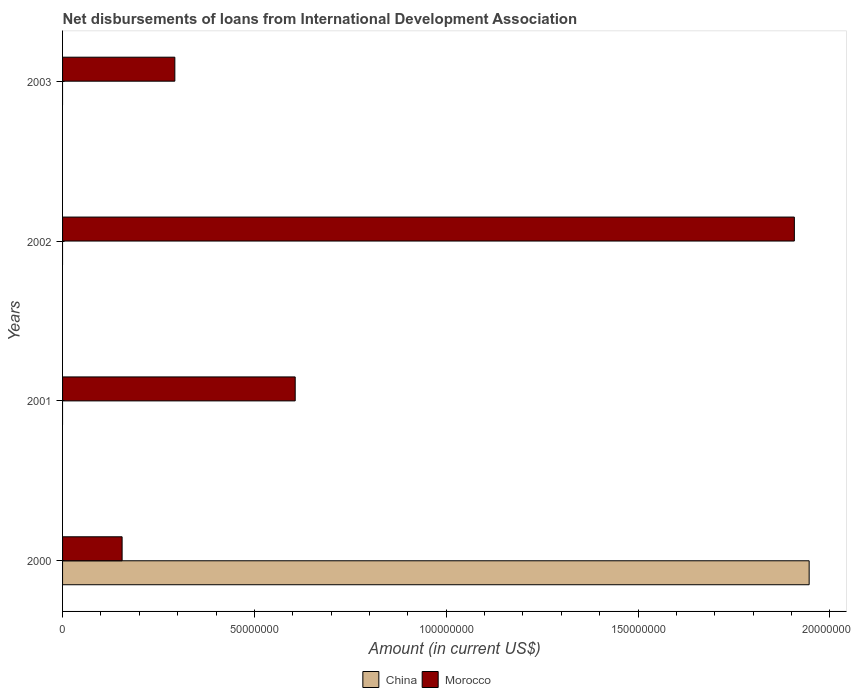Are the number of bars per tick equal to the number of legend labels?
Ensure brevity in your answer.  No. What is the label of the 3rd group of bars from the top?
Give a very brief answer. 2001. In how many cases, is the number of bars for a given year not equal to the number of legend labels?
Your response must be concise. 3. What is the amount of loans disbursed in Morocco in 2002?
Your response must be concise. 1.91e+08. Across all years, what is the maximum amount of loans disbursed in China?
Ensure brevity in your answer.  1.95e+08. Across all years, what is the minimum amount of loans disbursed in China?
Provide a succinct answer. 0. What is the total amount of loans disbursed in China in the graph?
Offer a very short reply. 1.95e+08. What is the difference between the amount of loans disbursed in Morocco in 2002 and that in 2003?
Ensure brevity in your answer.  1.61e+08. What is the difference between the amount of loans disbursed in Morocco in 2001 and the amount of loans disbursed in China in 2002?
Offer a terse response. 6.06e+07. What is the average amount of loans disbursed in China per year?
Offer a very short reply. 4.86e+07. In the year 2000, what is the difference between the amount of loans disbursed in Morocco and amount of loans disbursed in China?
Your response must be concise. -1.79e+08. In how many years, is the amount of loans disbursed in Morocco greater than 40000000 US$?
Provide a short and direct response. 2. What is the ratio of the amount of loans disbursed in Morocco in 2002 to that in 2003?
Provide a succinct answer. 6.52. Is the amount of loans disbursed in Morocco in 2000 less than that in 2003?
Offer a very short reply. Yes. What is the difference between the highest and the lowest amount of loans disbursed in Morocco?
Offer a terse response. 1.75e+08. Are the values on the major ticks of X-axis written in scientific E-notation?
Keep it short and to the point. No. Does the graph contain any zero values?
Ensure brevity in your answer.  Yes. Does the graph contain grids?
Provide a short and direct response. No. How many legend labels are there?
Provide a short and direct response. 2. How are the legend labels stacked?
Provide a succinct answer. Horizontal. What is the title of the graph?
Offer a terse response. Net disbursements of loans from International Development Association. What is the Amount (in current US$) in China in 2000?
Provide a succinct answer. 1.95e+08. What is the Amount (in current US$) of Morocco in 2000?
Your response must be concise. 1.55e+07. What is the Amount (in current US$) of China in 2001?
Your answer should be compact. 0. What is the Amount (in current US$) in Morocco in 2001?
Your response must be concise. 6.06e+07. What is the Amount (in current US$) of China in 2002?
Provide a succinct answer. 0. What is the Amount (in current US$) in Morocco in 2002?
Offer a terse response. 1.91e+08. What is the Amount (in current US$) of Morocco in 2003?
Your response must be concise. 2.93e+07. Across all years, what is the maximum Amount (in current US$) of China?
Give a very brief answer. 1.95e+08. Across all years, what is the maximum Amount (in current US$) of Morocco?
Provide a succinct answer. 1.91e+08. Across all years, what is the minimum Amount (in current US$) of Morocco?
Ensure brevity in your answer.  1.55e+07. What is the total Amount (in current US$) of China in the graph?
Make the answer very short. 1.95e+08. What is the total Amount (in current US$) in Morocco in the graph?
Give a very brief answer. 2.96e+08. What is the difference between the Amount (in current US$) of Morocco in 2000 and that in 2001?
Offer a terse response. -4.51e+07. What is the difference between the Amount (in current US$) of Morocco in 2000 and that in 2002?
Provide a succinct answer. -1.75e+08. What is the difference between the Amount (in current US$) of Morocco in 2000 and that in 2003?
Your answer should be very brief. -1.37e+07. What is the difference between the Amount (in current US$) of Morocco in 2001 and that in 2002?
Offer a terse response. -1.30e+08. What is the difference between the Amount (in current US$) in Morocco in 2001 and that in 2003?
Provide a short and direct response. 3.14e+07. What is the difference between the Amount (in current US$) of Morocco in 2002 and that in 2003?
Your answer should be very brief. 1.61e+08. What is the difference between the Amount (in current US$) in China in 2000 and the Amount (in current US$) in Morocco in 2001?
Your answer should be very brief. 1.34e+08. What is the difference between the Amount (in current US$) in China in 2000 and the Amount (in current US$) in Morocco in 2002?
Your answer should be compact. 3.86e+06. What is the difference between the Amount (in current US$) in China in 2000 and the Amount (in current US$) in Morocco in 2003?
Your response must be concise. 1.65e+08. What is the average Amount (in current US$) of China per year?
Offer a very short reply. 4.86e+07. What is the average Amount (in current US$) of Morocco per year?
Your answer should be very brief. 7.40e+07. In the year 2000, what is the difference between the Amount (in current US$) in China and Amount (in current US$) in Morocco?
Make the answer very short. 1.79e+08. What is the ratio of the Amount (in current US$) in Morocco in 2000 to that in 2001?
Offer a very short reply. 0.26. What is the ratio of the Amount (in current US$) of Morocco in 2000 to that in 2002?
Your answer should be compact. 0.08. What is the ratio of the Amount (in current US$) of Morocco in 2000 to that in 2003?
Offer a terse response. 0.53. What is the ratio of the Amount (in current US$) of Morocco in 2001 to that in 2002?
Provide a short and direct response. 0.32. What is the ratio of the Amount (in current US$) of Morocco in 2001 to that in 2003?
Keep it short and to the point. 2.07. What is the ratio of the Amount (in current US$) in Morocco in 2002 to that in 2003?
Make the answer very short. 6.52. What is the difference between the highest and the second highest Amount (in current US$) in Morocco?
Your answer should be very brief. 1.30e+08. What is the difference between the highest and the lowest Amount (in current US$) in China?
Your response must be concise. 1.95e+08. What is the difference between the highest and the lowest Amount (in current US$) of Morocco?
Provide a short and direct response. 1.75e+08. 